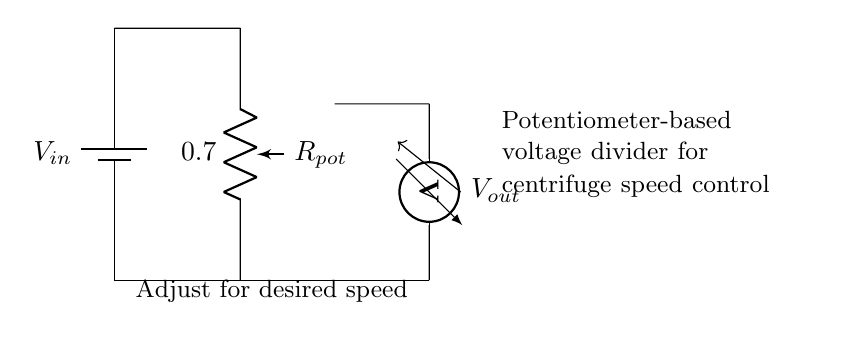What is the input voltage in this circuit? The input voltage is labeled as \( V_{in} \) at the top of the circuit, indicating the voltage supplied to the potentiometer.
Answer: Vin What component is used to adjust the output voltage? The potentiometer, labeled as \( R_{pot} \) in the circuit, serves to adjust the resistance, thus controlling the output voltage.
Answer: Potentiometer What is the relationship between input voltage and output voltage in this circuit? The output voltage \( V_{out} \) is determined by the voltage divider principle, which states that the output voltage is a fraction of the input voltage based on the resistances in the circuit.
Answer: Voltage divider What does the voltmeter measure in this circuit? The voltmeter, labeled as \( V_{out} \), measures the output voltage across the potentiometer, which adjusts the centrifuge speed.
Answer: Output voltage How does this circuit control the speed of the centrifuge? By adjusting the potentiometer, \( R_{pot} \), the voltage \( V_{out} \) is varied, which modulates the speed of the centrifuge in protein purification processes.
Answer: By adjusting output voltage What happens to \( V_{out} \) if the potentiometer resistance decreases? If the resistance of the potentiometer decreases, more voltage is dropped across the potentiometer, resulting in a higher output voltage \( V_{out} \).
Answer: Vout increases What is the function of the connection between the voltmeter and the ground in this circuit? The connection provides a reference point for the voltmeter to measure the output voltage accurately concerning the ground, allowing proper voltage readings.
Answer: Reference point 